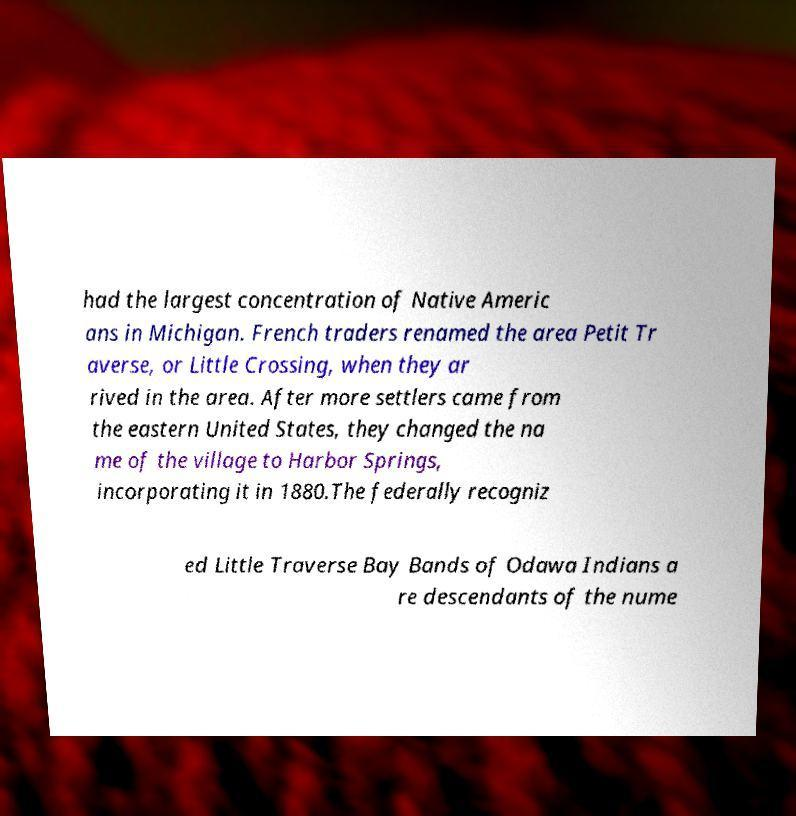Please identify and transcribe the text found in this image. had the largest concentration of Native Americ ans in Michigan. French traders renamed the area Petit Tr averse, or Little Crossing, when they ar rived in the area. After more settlers came from the eastern United States, they changed the na me of the village to Harbor Springs, incorporating it in 1880.The federally recogniz ed Little Traverse Bay Bands of Odawa Indians a re descendants of the nume 